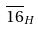Convert formula to latex. <formula><loc_0><loc_0><loc_500><loc_500>\overline { 1 6 } _ { H }</formula> 